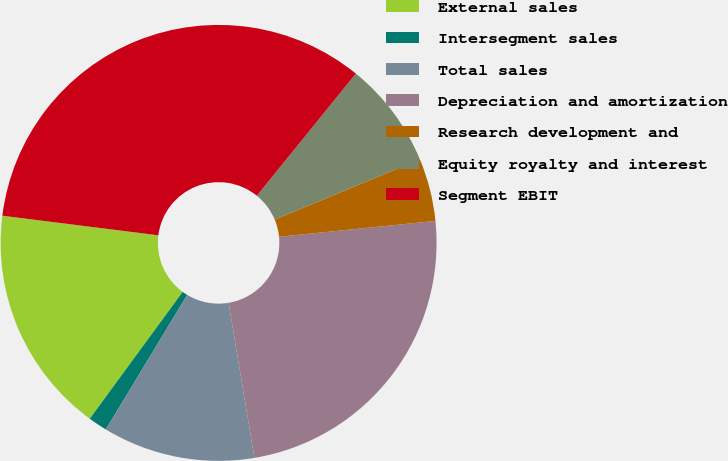Convert chart to OTSL. <chart><loc_0><loc_0><loc_500><loc_500><pie_chart><fcel>External sales<fcel>Intersegment sales<fcel>Total sales<fcel>Depreciation and amortization<fcel>Research development and<fcel>Equity royalty and interest<fcel>Segment EBIT<nl><fcel>16.93%<fcel>1.41%<fcel>11.28%<fcel>23.98%<fcel>4.65%<fcel>7.9%<fcel>33.85%<nl></chart> 